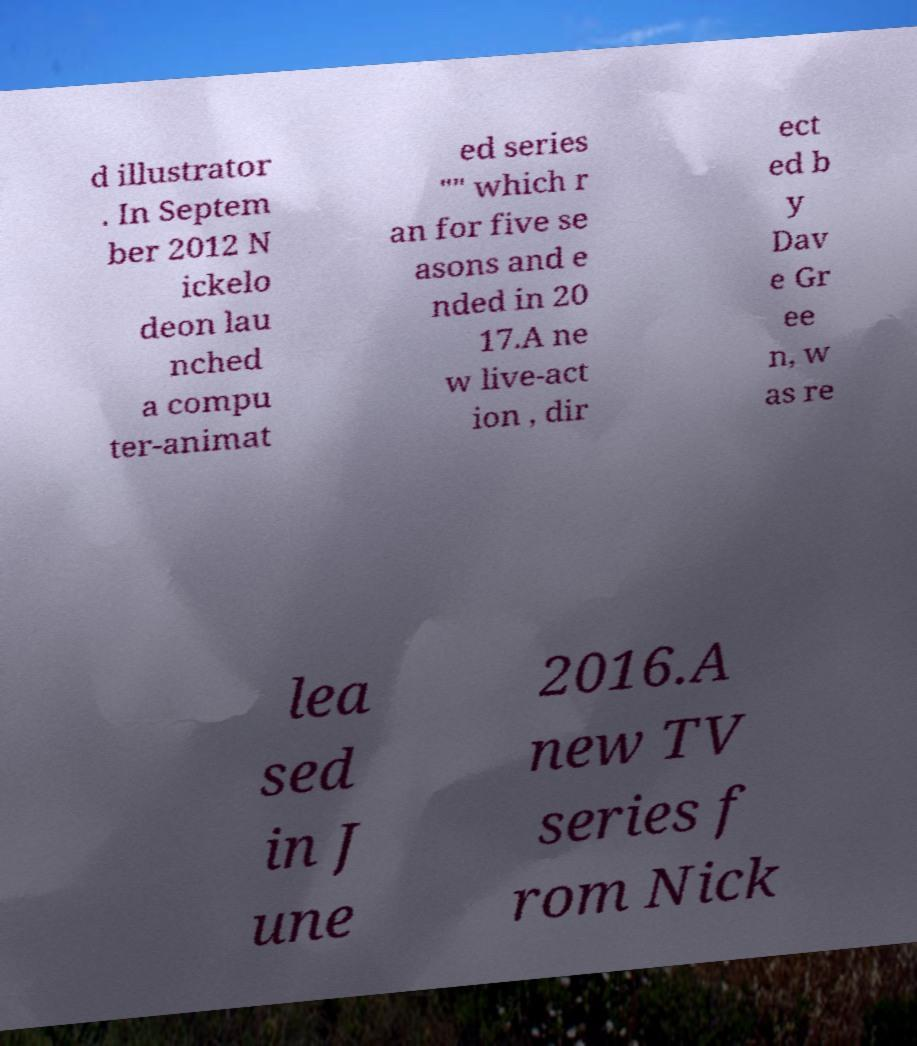For documentation purposes, I need the text within this image transcribed. Could you provide that? d illustrator . In Septem ber 2012 N ickelo deon lau nched a compu ter-animat ed series "" which r an for five se asons and e nded in 20 17.A ne w live-act ion , dir ect ed b y Dav e Gr ee n, w as re lea sed in J une 2016.A new TV series f rom Nick 